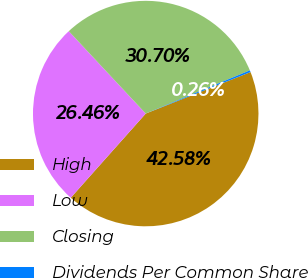Convert chart to OTSL. <chart><loc_0><loc_0><loc_500><loc_500><pie_chart><fcel>High<fcel>Low<fcel>Closing<fcel>Dividends Per Common Share<nl><fcel>42.58%<fcel>26.46%<fcel>30.7%<fcel>0.26%<nl></chart> 